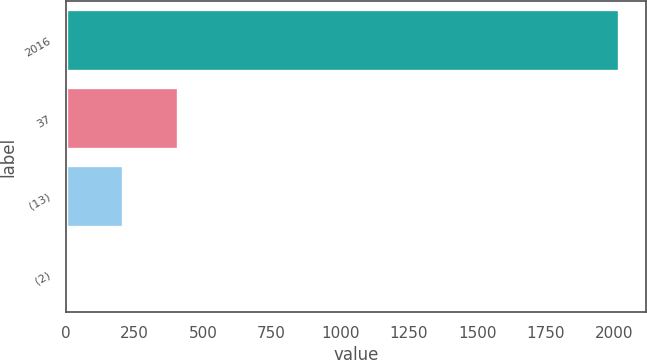Convert chart to OTSL. <chart><loc_0><loc_0><loc_500><loc_500><bar_chart><fcel>2016<fcel>37<fcel>(13)<fcel>(2)<nl><fcel>2015<fcel>409.4<fcel>208.7<fcel>8<nl></chart> 